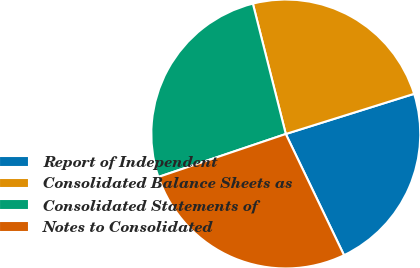Convert chart to OTSL. <chart><loc_0><loc_0><loc_500><loc_500><pie_chart><fcel>Report of Independent<fcel>Consolidated Balance Sheets as<fcel>Consolidated Statements of<fcel>Notes to Consolidated<nl><fcel>22.7%<fcel>24.11%<fcel>26.24%<fcel>26.95%<nl></chart> 